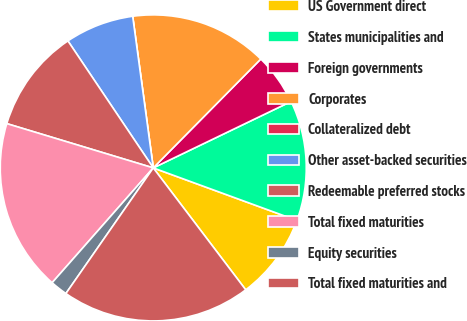Convert chart to OTSL. <chart><loc_0><loc_0><loc_500><loc_500><pie_chart><fcel>US Government direct<fcel>States municipalities and<fcel>Foreign governments<fcel>Corporates<fcel>Collateralized debt<fcel>Other asset-backed securities<fcel>Redeemable preferred stocks<fcel>Total fixed maturities<fcel>Equity securities<fcel>Total fixed maturities and<nl><fcel>9.09%<fcel>12.73%<fcel>5.45%<fcel>14.55%<fcel>0.0%<fcel>7.27%<fcel>10.91%<fcel>18.18%<fcel>1.82%<fcel>20.0%<nl></chart> 